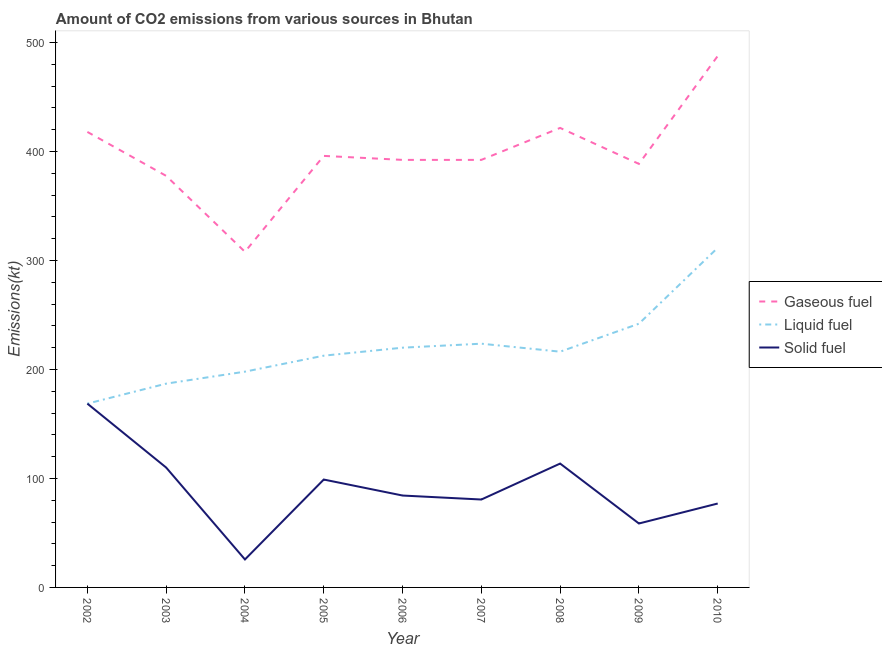Does the line corresponding to amount of co2 emissions from solid fuel intersect with the line corresponding to amount of co2 emissions from gaseous fuel?
Your response must be concise. No. Is the number of lines equal to the number of legend labels?
Offer a terse response. Yes. What is the amount of co2 emissions from solid fuel in 2006?
Your response must be concise. 84.34. Across all years, what is the maximum amount of co2 emissions from solid fuel?
Give a very brief answer. 168.68. Across all years, what is the minimum amount of co2 emissions from gaseous fuel?
Your response must be concise. 308.03. In which year was the amount of co2 emissions from gaseous fuel maximum?
Your answer should be very brief. 2010. In which year was the amount of co2 emissions from gaseous fuel minimum?
Your answer should be very brief. 2004. What is the total amount of co2 emissions from liquid fuel in the graph?
Your response must be concise. 1980.18. What is the difference between the amount of co2 emissions from gaseous fuel in 2008 and that in 2010?
Your response must be concise. -66.01. What is the difference between the amount of co2 emissions from gaseous fuel in 2010 and the amount of co2 emissions from solid fuel in 2009?
Keep it short and to the point. 429.04. What is the average amount of co2 emissions from gaseous fuel per year?
Offer a very short reply. 398.07. In the year 2010, what is the difference between the amount of co2 emissions from solid fuel and amount of co2 emissions from liquid fuel?
Offer a terse response. -234.69. In how many years, is the amount of co2 emissions from gaseous fuel greater than 120 kt?
Offer a very short reply. 9. What is the ratio of the amount of co2 emissions from gaseous fuel in 2005 to that in 2006?
Give a very brief answer. 1.01. Is the difference between the amount of co2 emissions from liquid fuel in 2002 and 2009 greater than the difference between the amount of co2 emissions from gaseous fuel in 2002 and 2009?
Your answer should be compact. No. What is the difference between the highest and the second highest amount of co2 emissions from liquid fuel?
Offer a very short reply. 69.67. What is the difference between the highest and the lowest amount of co2 emissions from solid fuel?
Your answer should be compact. 143.01. Is the sum of the amount of co2 emissions from liquid fuel in 2004 and 2008 greater than the maximum amount of co2 emissions from solid fuel across all years?
Keep it short and to the point. Yes. Is it the case that in every year, the sum of the amount of co2 emissions from gaseous fuel and amount of co2 emissions from liquid fuel is greater than the amount of co2 emissions from solid fuel?
Make the answer very short. Yes. Is the amount of co2 emissions from gaseous fuel strictly greater than the amount of co2 emissions from liquid fuel over the years?
Provide a short and direct response. Yes. Are the values on the major ticks of Y-axis written in scientific E-notation?
Ensure brevity in your answer.  No. Does the graph contain any zero values?
Offer a very short reply. No. Does the graph contain grids?
Your answer should be compact. No. How are the legend labels stacked?
Your answer should be compact. Vertical. What is the title of the graph?
Make the answer very short. Amount of CO2 emissions from various sources in Bhutan. What is the label or title of the Y-axis?
Your answer should be very brief. Emissions(kt). What is the Emissions(kt) in Gaseous fuel in 2002?
Give a very brief answer. 418.04. What is the Emissions(kt) of Liquid fuel in 2002?
Provide a short and direct response. 168.68. What is the Emissions(kt) of Solid fuel in 2002?
Ensure brevity in your answer.  168.68. What is the Emissions(kt) in Gaseous fuel in 2003?
Keep it short and to the point. 377.7. What is the Emissions(kt) in Liquid fuel in 2003?
Keep it short and to the point. 187.02. What is the Emissions(kt) of Solid fuel in 2003?
Your answer should be very brief. 110.01. What is the Emissions(kt) in Gaseous fuel in 2004?
Your answer should be compact. 308.03. What is the Emissions(kt) of Liquid fuel in 2004?
Provide a short and direct response. 198.02. What is the Emissions(kt) in Solid fuel in 2004?
Keep it short and to the point. 25.67. What is the Emissions(kt) in Gaseous fuel in 2005?
Keep it short and to the point. 396.04. What is the Emissions(kt) in Liquid fuel in 2005?
Provide a succinct answer. 212.69. What is the Emissions(kt) in Solid fuel in 2005?
Ensure brevity in your answer.  99.01. What is the Emissions(kt) in Gaseous fuel in 2006?
Keep it short and to the point. 392.37. What is the Emissions(kt) in Liquid fuel in 2006?
Provide a short and direct response. 220.02. What is the Emissions(kt) of Solid fuel in 2006?
Offer a very short reply. 84.34. What is the Emissions(kt) of Gaseous fuel in 2007?
Your answer should be very brief. 392.37. What is the Emissions(kt) of Liquid fuel in 2007?
Give a very brief answer. 223.69. What is the Emissions(kt) of Solid fuel in 2007?
Ensure brevity in your answer.  80.67. What is the Emissions(kt) of Gaseous fuel in 2008?
Give a very brief answer. 421.7. What is the Emissions(kt) in Liquid fuel in 2008?
Your response must be concise. 216.35. What is the Emissions(kt) in Solid fuel in 2008?
Offer a terse response. 113.68. What is the Emissions(kt) of Gaseous fuel in 2009?
Offer a very short reply. 388.7. What is the Emissions(kt) of Liquid fuel in 2009?
Keep it short and to the point. 242.02. What is the Emissions(kt) in Solid fuel in 2009?
Make the answer very short. 58.67. What is the Emissions(kt) of Gaseous fuel in 2010?
Your response must be concise. 487.71. What is the Emissions(kt) of Liquid fuel in 2010?
Offer a terse response. 311.69. What is the Emissions(kt) of Solid fuel in 2010?
Keep it short and to the point. 77.01. Across all years, what is the maximum Emissions(kt) of Gaseous fuel?
Give a very brief answer. 487.71. Across all years, what is the maximum Emissions(kt) of Liquid fuel?
Keep it short and to the point. 311.69. Across all years, what is the maximum Emissions(kt) of Solid fuel?
Give a very brief answer. 168.68. Across all years, what is the minimum Emissions(kt) of Gaseous fuel?
Offer a terse response. 308.03. Across all years, what is the minimum Emissions(kt) in Liquid fuel?
Your answer should be very brief. 168.68. Across all years, what is the minimum Emissions(kt) in Solid fuel?
Your answer should be very brief. 25.67. What is the total Emissions(kt) in Gaseous fuel in the graph?
Provide a short and direct response. 3582.66. What is the total Emissions(kt) of Liquid fuel in the graph?
Ensure brevity in your answer.  1980.18. What is the total Emissions(kt) in Solid fuel in the graph?
Offer a terse response. 817.74. What is the difference between the Emissions(kt) in Gaseous fuel in 2002 and that in 2003?
Offer a very short reply. 40.34. What is the difference between the Emissions(kt) of Liquid fuel in 2002 and that in 2003?
Keep it short and to the point. -18.34. What is the difference between the Emissions(kt) in Solid fuel in 2002 and that in 2003?
Provide a short and direct response. 58.67. What is the difference between the Emissions(kt) of Gaseous fuel in 2002 and that in 2004?
Provide a succinct answer. 110.01. What is the difference between the Emissions(kt) of Liquid fuel in 2002 and that in 2004?
Your answer should be very brief. -29.34. What is the difference between the Emissions(kt) in Solid fuel in 2002 and that in 2004?
Ensure brevity in your answer.  143.01. What is the difference between the Emissions(kt) in Gaseous fuel in 2002 and that in 2005?
Ensure brevity in your answer.  22. What is the difference between the Emissions(kt) in Liquid fuel in 2002 and that in 2005?
Give a very brief answer. -44. What is the difference between the Emissions(kt) of Solid fuel in 2002 and that in 2005?
Ensure brevity in your answer.  69.67. What is the difference between the Emissions(kt) in Gaseous fuel in 2002 and that in 2006?
Make the answer very short. 25.67. What is the difference between the Emissions(kt) of Liquid fuel in 2002 and that in 2006?
Offer a very short reply. -51.34. What is the difference between the Emissions(kt) in Solid fuel in 2002 and that in 2006?
Provide a succinct answer. 84.34. What is the difference between the Emissions(kt) in Gaseous fuel in 2002 and that in 2007?
Provide a short and direct response. 25.67. What is the difference between the Emissions(kt) in Liquid fuel in 2002 and that in 2007?
Offer a very short reply. -55.01. What is the difference between the Emissions(kt) in Solid fuel in 2002 and that in 2007?
Provide a succinct answer. 88.01. What is the difference between the Emissions(kt) in Gaseous fuel in 2002 and that in 2008?
Provide a short and direct response. -3.67. What is the difference between the Emissions(kt) of Liquid fuel in 2002 and that in 2008?
Give a very brief answer. -47.67. What is the difference between the Emissions(kt) in Solid fuel in 2002 and that in 2008?
Give a very brief answer. 55.01. What is the difference between the Emissions(kt) in Gaseous fuel in 2002 and that in 2009?
Your answer should be very brief. 29.34. What is the difference between the Emissions(kt) of Liquid fuel in 2002 and that in 2009?
Make the answer very short. -73.34. What is the difference between the Emissions(kt) of Solid fuel in 2002 and that in 2009?
Ensure brevity in your answer.  110.01. What is the difference between the Emissions(kt) in Gaseous fuel in 2002 and that in 2010?
Ensure brevity in your answer.  -69.67. What is the difference between the Emissions(kt) in Liquid fuel in 2002 and that in 2010?
Your answer should be compact. -143.01. What is the difference between the Emissions(kt) in Solid fuel in 2002 and that in 2010?
Provide a succinct answer. 91.67. What is the difference between the Emissions(kt) of Gaseous fuel in 2003 and that in 2004?
Ensure brevity in your answer.  69.67. What is the difference between the Emissions(kt) of Liquid fuel in 2003 and that in 2004?
Give a very brief answer. -11. What is the difference between the Emissions(kt) in Solid fuel in 2003 and that in 2004?
Give a very brief answer. 84.34. What is the difference between the Emissions(kt) in Gaseous fuel in 2003 and that in 2005?
Give a very brief answer. -18.34. What is the difference between the Emissions(kt) in Liquid fuel in 2003 and that in 2005?
Give a very brief answer. -25.67. What is the difference between the Emissions(kt) in Solid fuel in 2003 and that in 2005?
Give a very brief answer. 11. What is the difference between the Emissions(kt) of Gaseous fuel in 2003 and that in 2006?
Your answer should be very brief. -14.67. What is the difference between the Emissions(kt) in Liquid fuel in 2003 and that in 2006?
Your answer should be compact. -33. What is the difference between the Emissions(kt) of Solid fuel in 2003 and that in 2006?
Your response must be concise. 25.67. What is the difference between the Emissions(kt) of Gaseous fuel in 2003 and that in 2007?
Offer a terse response. -14.67. What is the difference between the Emissions(kt) of Liquid fuel in 2003 and that in 2007?
Offer a very short reply. -36.67. What is the difference between the Emissions(kt) of Solid fuel in 2003 and that in 2007?
Your response must be concise. 29.34. What is the difference between the Emissions(kt) in Gaseous fuel in 2003 and that in 2008?
Give a very brief answer. -44. What is the difference between the Emissions(kt) in Liquid fuel in 2003 and that in 2008?
Your answer should be very brief. -29.34. What is the difference between the Emissions(kt) of Solid fuel in 2003 and that in 2008?
Your response must be concise. -3.67. What is the difference between the Emissions(kt) in Gaseous fuel in 2003 and that in 2009?
Keep it short and to the point. -11. What is the difference between the Emissions(kt) in Liquid fuel in 2003 and that in 2009?
Ensure brevity in your answer.  -55.01. What is the difference between the Emissions(kt) of Solid fuel in 2003 and that in 2009?
Offer a very short reply. 51.34. What is the difference between the Emissions(kt) of Gaseous fuel in 2003 and that in 2010?
Make the answer very short. -110.01. What is the difference between the Emissions(kt) in Liquid fuel in 2003 and that in 2010?
Your response must be concise. -124.68. What is the difference between the Emissions(kt) of Solid fuel in 2003 and that in 2010?
Your answer should be compact. 33. What is the difference between the Emissions(kt) in Gaseous fuel in 2004 and that in 2005?
Your answer should be compact. -88.01. What is the difference between the Emissions(kt) of Liquid fuel in 2004 and that in 2005?
Your answer should be compact. -14.67. What is the difference between the Emissions(kt) of Solid fuel in 2004 and that in 2005?
Ensure brevity in your answer.  -73.34. What is the difference between the Emissions(kt) of Gaseous fuel in 2004 and that in 2006?
Your answer should be very brief. -84.34. What is the difference between the Emissions(kt) in Liquid fuel in 2004 and that in 2006?
Offer a terse response. -22. What is the difference between the Emissions(kt) in Solid fuel in 2004 and that in 2006?
Give a very brief answer. -58.67. What is the difference between the Emissions(kt) of Gaseous fuel in 2004 and that in 2007?
Offer a terse response. -84.34. What is the difference between the Emissions(kt) in Liquid fuel in 2004 and that in 2007?
Offer a terse response. -25.67. What is the difference between the Emissions(kt) in Solid fuel in 2004 and that in 2007?
Make the answer very short. -55.01. What is the difference between the Emissions(kt) of Gaseous fuel in 2004 and that in 2008?
Ensure brevity in your answer.  -113.68. What is the difference between the Emissions(kt) in Liquid fuel in 2004 and that in 2008?
Offer a very short reply. -18.34. What is the difference between the Emissions(kt) of Solid fuel in 2004 and that in 2008?
Keep it short and to the point. -88.01. What is the difference between the Emissions(kt) of Gaseous fuel in 2004 and that in 2009?
Your answer should be very brief. -80.67. What is the difference between the Emissions(kt) in Liquid fuel in 2004 and that in 2009?
Offer a terse response. -44. What is the difference between the Emissions(kt) of Solid fuel in 2004 and that in 2009?
Provide a succinct answer. -33. What is the difference between the Emissions(kt) of Gaseous fuel in 2004 and that in 2010?
Keep it short and to the point. -179.68. What is the difference between the Emissions(kt) in Liquid fuel in 2004 and that in 2010?
Give a very brief answer. -113.68. What is the difference between the Emissions(kt) of Solid fuel in 2004 and that in 2010?
Ensure brevity in your answer.  -51.34. What is the difference between the Emissions(kt) in Gaseous fuel in 2005 and that in 2006?
Make the answer very short. 3.67. What is the difference between the Emissions(kt) of Liquid fuel in 2005 and that in 2006?
Offer a terse response. -7.33. What is the difference between the Emissions(kt) of Solid fuel in 2005 and that in 2006?
Keep it short and to the point. 14.67. What is the difference between the Emissions(kt) in Gaseous fuel in 2005 and that in 2007?
Your answer should be very brief. 3.67. What is the difference between the Emissions(kt) in Liquid fuel in 2005 and that in 2007?
Provide a short and direct response. -11. What is the difference between the Emissions(kt) of Solid fuel in 2005 and that in 2007?
Make the answer very short. 18.34. What is the difference between the Emissions(kt) of Gaseous fuel in 2005 and that in 2008?
Provide a short and direct response. -25.67. What is the difference between the Emissions(kt) in Liquid fuel in 2005 and that in 2008?
Provide a succinct answer. -3.67. What is the difference between the Emissions(kt) in Solid fuel in 2005 and that in 2008?
Ensure brevity in your answer.  -14.67. What is the difference between the Emissions(kt) of Gaseous fuel in 2005 and that in 2009?
Your answer should be very brief. 7.33. What is the difference between the Emissions(kt) in Liquid fuel in 2005 and that in 2009?
Your response must be concise. -29.34. What is the difference between the Emissions(kt) in Solid fuel in 2005 and that in 2009?
Give a very brief answer. 40.34. What is the difference between the Emissions(kt) of Gaseous fuel in 2005 and that in 2010?
Your answer should be very brief. -91.67. What is the difference between the Emissions(kt) in Liquid fuel in 2005 and that in 2010?
Offer a very short reply. -99.01. What is the difference between the Emissions(kt) of Solid fuel in 2005 and that in 2010?
Make the answer very short. 22. What is the difference between the Emissions(kt) in Gaseous fuel in 2006 and that in 2007?
Provide a succinct answer. 0. What is the difference between the Emissions(kt) of Liquid fuel in 2006 and that in 2007?
Your response must be concise. -3.67. What is the difference between the Emissions(kt) in Solid fuel in 2006 and that in 2007?
Offer a very short reply. 3.67. What is the difference between the Emissions(kt) of Gaseous fuel in 2006 and that in 2008?
Offer a terse response. -29.34. What is the difference between the Emissions(kt) of Liquid fuel in 2006 and that in 2008?
Provide a short and direct response. 3.67. What is the difference between the Emissions(kt) of Solid fuel in 2006 and that in 2008?
Keep it short and to the point. -29.34. What is the difference between the Emissions(kt) in Gaseous fuel in 2006 and that in 2009?
Provide a short and direct response. 3.67. What is the difference between the Emissions(kt) in Liquid fuel in 2006 and that in 2009?
Offer a terse response. -22. What is the difference between the Emissions(kt) in Solid fuel in 2006 and that in 2009?
Keep it short and to the point. 25.67. What is the difference between the Emissions(kt) in Gaseous fuel in 2006 and that in 2010?
Provide a succinct answer. -95.34. What is the difference between the Emissions(kt) of Liquid fuel in 2006 and that in 2010?
Keep it short and to the point. -91.67. What is the difference between the Emissions(kt) of Solid fuel in 2006 and that in 2010?
Keep it short and to the point. 7.33. What is the difference between the Emissions(kt) in Gaseous fuel in 2007 and that in 2008?
Keep it short and to the point. -29.34. What is the difference between the Emissions(kt) of Liquid fuel in 2007 and that in 2008?
Offer a terse response. 7.33. What is the difference between the Emissions(kt) in Solid fuel in 2007 and that in 2008?
Provide a short and direct response. -33. What is the difference between the Emissions(kt) of Gaseous fuel in 2007 and that in 2009?
Keep it short and to the point. 3.67. What is the difference between the Emissions(kt) of Liquid fuel in 2007 and that in 2009?
Offer a terse response. -18.34. What is the difference between the Emissions(kt) of Solid fuel in 2007 and that in 2009?
Keep it short and to the point. 22. What is the difference between the Emissions(kt) in Gaseous fuel in 2007 and that in 2010?
Your response must be concise. -95.34. What is the difference between the Emissions(kt) of Liquid fuel in 2007 and that in 2010?
Your response must be concise. -88.01. What is the difference between the Emissions(kt) of Solid fuel in 2007 and that in 2010?
Offer a very short reply. 3.67. What is the difference between the Emissions(kt) in Gaseous fuel in 2008 and that in 2009?
Ensure brevity in your answer.  33. What is the difference between the Emissions(kt) in Liquid fuel in 2008 and that in 2009?
Make the answer very short. -25.67. What is the difference between the Emissions(kt) of Solid fuel in 2008 and that in 2009?
Provide a succinct answer. 55.01. What is the difference between the Emissions(kt) in Gaseous fuel in 2008 and that in 2010?
Your response must be concise. -66.01. What is the difference between the Emissions(kt) in Liquid fuel in 2008 and that in 2010?
Ensure brevity in your answer.  -95.34. What is the difference between the Emissions(kt) in Solid fuel in 2008 and that in 2010?
Offer a terse response. 36.67. What is the difference between the Emissions(kt) of Gaseous fuel in 2009 and that in 2010?
Your response must be concise. -99.01. What is the difference between the Emissions(kt) of Liquid fuel in 2009 and that in 2010?
Offer a terse response. -69.67. What is the difference between the Emissions(kt) of Solid fuel in 2009 and that in 2010?
Provide a succinct answer. -18.34. What is the difference between the Emissions(kt) of Gaseous fuel in 2002 and the Emissions(kt) of Liquid fuel in 2003?
Your answer should be compact. 231.02. What is the difference between the Emissions(kt) in Gaseous fuel in 2002 and the Emissions(kt) in Solid fuel in 2003?
Your response must be concise. 308.03. What is the difference between the Emissions(kt) in Liquid fuel in 2002 and the Emissions(kt) in Solid fuel in 2003?
Give a very brief answer. 58.67. What is the difference between the Emissions(kt) of Gaseous fuel in 2002 and the Emissions(kt) of Liquid fuel in 2004?
Give a very brief answer. 220.02. What is the difference between the Emissions(kt) in Gaseous fuel in 2002 and the Emissions(kt) in Solid fuel in 2004?
Provide a succinct answer. 392.37. What is the difference between the Emissions(kt) in Liquid fuel in 2002 and the Emissions(kt) in Solid fuel in 2004?
Keep it short and to the point. 143.01. What is the difference between the Emissions(kt) in Gaseous fuel in 2002 and the Emissions(kt) in Liquid fuel in 2005?
Ensure brevity in your answer.  205.35. What is the difference between the Emissions(kt) of Gaseous fuel in 2002 and the Emissions(kt) of Solid fuel in 2005?
Keep it short and to the point. 319.03. What is the difference between the Emissions(kt) of Liquid fuel in 2002 and the Emissions(kt) of Solid fuel in 2005?
Offer a terse response. 69.67. What is the difference between the Emissions(kt) of Gaseous fuel in 2002 and the Emissions(kt) of Liquid fuel in 2006?
Provide a succinct answer. 198.02. What is the difference between the Emissions(kt) in Gaseous fuel in 2002 and the Emissions(kt) in Solid fuel in 2006?
Provide a succinct answer. 333.7. What is the difference between the Emissions(kt) in Liquid fuel in 2002 and the Emissions(kt) in Solid fuel in 2006?
Offer a terse response. 84.34. What is the difference between the Emissions(kt) in Gaseous fuel in 2002 and the Emissions(kt) in Liquid fuel in 2007?
Provide a short and direct response. 194.35. What is the difference between the Emissions(kt) of Gaseous fuel in 2002 and the Emissions(kt) of Solid fuel in 2007?
Your answer should be very brief. 337.36. What is the difference between the Emissions(kt) of Liquid fuel in 2002 and the Emissions(kt) of Solid fuel in 2007?
Your answer should be very brief. 88.01. What is the difference between the Emissions(kt) in Gaseous fuel in 2002 and the Emissions(kt) in Liquid fuel in 2008?
Provide a succinct answer. 201.69. What is the difference between the Emissions(kt) of Gaseous fuel in 2002 and the Emissions(kt) of Solid fuel in 2008?
Make the answer very short. 304.36. What is the difference between the Emissions(kt) in Liquid fuel in 2002 and the Emissions(kt) in Solid fuel in 2008?
Your answer should be compact. 55.01. What is the difference between the Emissions(kt) in Gaseous fuel in 2002 and the Emissions(kt) in Liquid fuel in 2009?
Keep it short and to the point. 176.02. What is the difference between the Emissions(kt) in Gaseous fuel in 2002 and the Emissions(kt) in Solid fuel in 2009?
Provide a succinct answer. 359.37. What is the difference between the Emissions(kt) of Liquid fuel in 2002 and the Emissions(kt) of Solid fuel in 2009?
Offer a very short reply. 110.01. What is the difference between the Emissions(kt) of Gaseous fuel in 2002 and the Emissions(kt) of Liquid fuel in 2010?
Your response must be concise. 106.34. What is the difference between the Emissions(kt) of Gaseous fuel in 2002 and the Emissions(kt) of Solid fuel in 2010?
Make the answer very short. 341.03. What is the difference between the Emissions(kt) in Liquid fuel in 2002 and the Emissions(kt) in Solid fuel in 2010?
Provide a short and direct response. 91.67. What is the difference between the Emissions(kt) of Gaseous fuel in 2003 and the Emissions(kt) of Liquid fuel in 2004?
Give a very brief answer. 179.68. What is the difference between the Emissions(kt) of Gaseous fuel in 2003 and the Emissions(kt) of Solid fuel in 2004?
Ensure brevity in your answer.  352.03. What is the difference between the Emissions(kt) of Liquid fuel in 2003 and the Emissions(kt) of Solid fuel in 2004?
Your response must be concise. 161.35. What is the difference between the Emissions(kt) in Gaseous fuel in 2003 and the Emissions(kt) in Liquid fuel in 2005?
Give a very brief answer. 165.01. What is the difference between the Emissions(kt) in Gaseous fuel in 2003 and the Emissions(kt) in Solid fuel in 2005?
Your answer should be compact. 278.69. What is the difference between the Emissions(kt) of Liquid fuel in 2003 and the Emissions(kt) of Solid fuel in 2005?
Your response must be concise. 88.01. What is the difference between the Emissions(kt) of Gaseous fuel in 2003 and the Emissions(kt) of Liquid fuel in 2006?
Give a very brief answer. 157.68. What is the difference between the Emissions(kt) of Gaseous fuel in 2003 and the Emissions(kt) of Solid fuel in 2006?
Offer a very short reply. 293.36. What is the difference between the Emissions(kt) of Liquid fuel in 2003 and the Emissions(kt) of Solid fuel in 2006?
Provide a short and direct response. 102.68. What is the difference between the Emissions(kt) in Gaseous fuel in 2003 and the Emissions(kt) in Liquid fuel in 2007?
Give a very brief answer. 154.01. What is the difference between the Emissions(kt) in Gaseous fuel in 2003 and the Emissions(kt) in Solid fuel in 2007?
Make the answer very short. 297.03. What is the difference between the Emissions(kt) of Liquid fuel in 2003 and the Emissions(kt) of Solid fuel in 2007?
Offer a very short reply. 106.34. What is the difference between the Emissions(kt) of Gaseous fuel in 2003 and the Emissions(kt) of Liquid fuel in 2008?
Provide a succinct answer. 161.35. What is the difference between the Emissions(kt) of Gaseous fuel in 2003 and the Emissions(kt) of Solid fuel in 2008?
Give a very brief answer. 264.02. What is the difference between the Emissions(kt) of Liquid fuel in 2003 and the Emissions(kt) of Solid fuel in 2008?
Your response must be concise. 73.34. What is the difference between the Emissions(kt) of Gaseous fuel in 2003 and the Emissions(kt) of Liquid fuel in 2009?
Provide a short and direct response. 135.68. What is the difference between the Emissions(kt) in Gaseous fuel in 2003 and the Emissions(kt) in Solid fuel in 2009?
Make the answer very short. 319.03. What is the difference between the Emissions(kt) in Liquid fuel in 2003 and the Emissions(kt) in Solid fuel in 2009?
Provide a short and direct response. 128.34. What is the difference between the Emissions(kt) in Gaseous fuel in 2003 and the Emissions(kt) in Liquid fuel in 2010?
Keep it short and to the point. 66.01. What is the difference between the Emissions(kt) of Gaseous fuel in 2003 and the Emissions(kt) of Solid fuel in 2010?
Offer a terse response. 300.69. What is the difference between the Emissions(kt) of Liquid fuel in 2003 and the Emissions(kt) of Solid fuel in 2010?
Your response must be concise. 110.01. What is the difference between the Emissions(kt) of Gaseous fuel in 2004 and the Emissions(kt) of Liquid fuel in 2005?
Keep it short and to the point. 95.34. What is the difference between the Emissions(kt) of Gaseous fuel in 2004 and the Emissions(kt) of Solid fuel in 2005?
Make the answer very short. 209.02. What is the difference between the Emissions(kt) in Liquid fuel in 2004 and the Emissions(kt) in Solid fuel in 2005?
Provide a succinct answer. 99.01. What is the difference between the Emissions(kt) in Gaseous fuel in 2004 and the Emissions(kt) in Liquid fuel in 2006?
Make the answer very short. 88.01. What is the difference between the Emissions(kt) of Gaseous fuel in 2004 and the Emissions(kt) of Solid fuel in 2006?
Offer a terse response. 223.69. What is the difference between the Emissions(kt) of Liquid fuel in 2004 and the Emissions(kt) of Solid fuel in 2006?
Provide a short and direct response. 113.68. What is the difference between the Emissions(kt) of Gaseous fuel in 2004 and the Emissions(kt) of Liquid fuel in 2007?
Offer a very short reply. 84.34. What is the difference between the Emissions(kt) in Gaseous fuel in 2004 and the Emissions(kt) in Solid fuel in 2007?
Make the answer very short. 227.35. What is the difference between the Emissions(kt) of Liquid fuel in 2004 and the Emissions(kt) of Solid fuel in 2007?
Provide a succinct answer. 117.34. What is the difference between the Emissions(kt) of Gaseous fuel in 2004 and the Emissions(kt) of Liquid fuel in 2008?
Offer a terse response. 91.67. What is the difference between the Emissions(kt) of Gaseous fuel in 2004 and the Emissions(kt) of Solid fuel in 2008?
Make the answer very short. 194.35. What is the difference between the Emissions(kt) of Liquid fuel in 2004 and the Emissions(kt) of Solid fuel in 2008?
Offer a terse response. 84.34. What is the difference between the Emissions(kt) in Gaseous fuel in 2004 and the Emissions(kt) in Liquid fuel in 2009?
Provide a succinct answer. 66.01. What is the difference between the Emissions(kt) of Gaseous fuel in 2004 and the Emissions(kt) of Solid fuel in 2009?
Your response must be concise. 249.36. What is the difference between the Emissions(kt) of Liquid fuel in 2004 and the Emissions(kt) of Solid fuel in 2009?
Your answer should be compact. 139.35. What is the difference between the Emissions(kt) of Gaseous fuel in 2004 and the Emissions(kt) of Liquid fuel in 2010?
Offer a terse response. -3.67. What is the difference between the Emissions(kt) in Gaseous fuel in 2004 and the Emissions(kt) in Solid fuel in 2010?
Offer a terse response. 231.02. What is the difference between the Emissions(kt) in Liquid fuel in 2004 and the Emissions(kt) in Solid fuel in 2010?
Your answer should be very brief. 121.01. What is the difference between the Emissions(kt) in Gaseous fuel in 2005 and the Emissions(kt) in Liquid fuel in 2006?
Give a very brief answer. 176.02. What is the difference between the Emissions(kt) of Gaseous fuel in 2005 and the Emissions(kt) of Solid fuel in 2006?
Offer a very short reply. 311.69. What is the difference between the Emissions(kt) in Liquid fuel in 2005 and the Emissions(kt) in Solid fuel in 2006?
Give a very brief answer. 128.34. What is the difference between the Emissions(kt) of Gaseous fuel in 2005 and the Emissions(kt) of Liquid fuel in 2007?
Provide a short and direct response. 172.35. What is the difference between the Emissions(kt) in Gaseous fuel in 2005 and the Emissions(kt) in Solid fuel in 2007?
Your response must be concise. 315.36. What is the difference between the Emissions(kt) of Liquid fuel in 2005 and the Emissions(kt) of Solid fuel in 2007?
Provide a succinct answer. 132.01. What is the difference between the Emissions(kt) in Gaseous fuel in 2005 and the Emissions(kt) in Liquid fuel in 2008?
Give a very brief answer. 179.68. What is the difference between the Emissions(kt) in Gaseous fuel in 2005 and the Emissions(kt) in Solid fuel in 2008?
Provide a short and direct response. 282.36. What is the difference between the Emissions(kt) of Liquid fuel in 2005 and the Emissions(kt) of Solid fuel in 2008?
Provide a short and direct response. 99.01. What is the difference between the Emissions(kt) of Gaseous fuel in 2005 and the Emissions(kt) of Liquid fuel in 2009?
Offer a terse response. 154.01. What is the difference between the Emissions(kt) of Gaseous fuel in 2005 and the Emissions(kt) of Solid fuel in 2009?
Make the answer very short. 337.36. What is the difference between the Emissions(kt) in Liquid fuel in 2005 and the Emissions(kt) in Solid fuel in 2009?
Make the answer very short. 154.01. What is the difference between the Emissions(kt) of Gaseous fuel in 2005 and the Emissions(kt) of Liquid fuel in 2010?
Keep it short and to the point. 84.34. What is the difference between the Emissions(kt) of Gaseous fuel in 2005 and the Emissions(kt) of Solid fuel in 2010?
Offer a terse response. 319.03. What is the difference between the Emissions(kt) of Liquid fuel in 2005 and the Emissions(kt) of Solid fuel in 2010?
Your response must be concise. 135.68. What is the difference between the Emissions(kt) in Gaseous fuel in 2006 and the Emissions(kt) in Liquid fuel in 2007?
Provide a succinct answer. 168.68. What is the difference between the Emissions(kt) of Gaseous fuel in 2006 and the Emissions(kt) of Solid fuel in 2007?
Make the answer very short. 311.69. What is the difference between the Emissions(kt) in Liquid fuel in 2006 and the Emissions(kt) in Solid fuel in 2007?
Make the answer very short. 139.35. What is the difference between the Emissions(kt) of Gaseous fuel in 2006 and the Emissions(kt) of Liquid fuel in 2008?
Ensure brevity in your answer.  176.02. What is the difference between the Emissions(kt) in Gaseous fuel in 2006 and the Emissions(kt) in Solid fuel in 2008?
Keep it short and to the point. 278.69. What is the difference between the Emissions(kt) of Liquid fuel in 2006 and the Emissions(kt) of Solid fuel in 2008?
Give a very brief answer. 106.34. What is the difference between the Emissions(kt) in Gaseous fuel in 2006 and the Emissions(kt) in Liquid fuel in 2009?
Your response must be concise. 150.35. What is the difference between the Emissions(kt) of Gaseous fuel in 2006 and the Emissions(kt) of Solid fuel in 2009?
Provide a succinct answer. 333.7. What is the difference between the Emissions(kt) in Liquid fuel in 2006 and the Emissions(kt) in Solid fuel in 2009?
Give a very brief answer. 161.35. What is the difference between the Emissions(kt) in Gaseous fuel in 2006 and the Emissions(kt) in Liquid fuel in 2010?
Your answer should be compact. 80.67. What is the difference between the Emissions(kt) in Gaseous fuel in 2006 and the Emissions(kt) in Solid fuel in 2010?
Provide a short and direct response. 315.36. What is the difference between the Emissions(kt) in Liquid fuel in 2006 and the Emissions(kt) in Solid fuel in 2010?
Keep it short and to the point. 143.01. What is the difference between the Emissions(kt) in Gaseous fuel in 2007 and the Emissions(kt) in Liquid fuel in 2008?
Your answer should be compact. 176.02. What is the difference between the Emissions(kt) of Gaseous fuel in 2007 and the Emissions(kt) of Solid fuel in 2008?
Offer a very short reply. 278.69. What is the difference between the Emissions(kt) of Liquid fuel in 2007 and the Emissions(kt) of Solid fuel in 2008?
Offer a very short reply. 110.01. What is the difference between the Emissions(kt) in Gaseous fuel in 2007 and the Emissions(kt) in Liquid fuel in 2009?
Provide a short and direct response. 150.35. What is the difference between the Emissions(kt) in Gaseous fuel in 2007 and the Emissions(kt) in Solid fuel in 2009?
Give a very brief answer. 333.7. What is the difference between the Emissions(kt) in Liquid fuel in 2007 and the Emissions(kt) in Solid fuel in 2009?
Ensure brevity in your answer.  165.01. What is the difference between the Emissions(kt) in Gaseous fuel in 2007 and the Emissions(kt) in Liquid fuel in 2010?
Keep it short and to the point. 80.67. What is the difference between the Emissions(kt) in Gaseous fuel in 2007 and the Emissions(kt) in Solid fuel in 2010?
Your response must be concise. 315.36. What is the difference between the Emissions(kt) in Liquid fuel in 2007 and the Emissions(kt) in Solid fuel in 2010?
Your answer should be compact. 146.68. What is the difference between the Emissions(kt) of Gaseous fuel in 2008 and the Emissions(kt) of Liquid fuel in 2009?
Provide a short and direct response. 179.68. What is the difference between the Emissions(kt) in Gaseous fuel in 2008 and the Emissions(kt) in Solid fuel in 2009?
Offer a terse response. 363.03. What is the difference between the Emissions(kt) of Liquid fuel in 2008 and the Emissions(kt) of Solid fuel in 2009?
Give a very brief answer. 157.68. What is the difference between the Emissions(kt) in Gaseous fuel in 2008 and the Emissions(kt) in Liquid fuel in 2010?
Your answer should be compact. 110.01. What is the difference between the Emissions(kt) in Gaseous fuel in 2008 and the Emissions(kt) in Solid fuel in 2010?
Your answer should be compact. 344.7. What is the difference between the Emissions(kt) in Liquid fuel in 2008 and the Emissions(kt) in Solid fuel in 2010?
Give a very brief answer. 139.35. What is the difference between the Emissions(kt) in Gaseous fuel in 2009 and the Emissions(kt) in Liquid fuel in 2010?
Your response must be concise. 77.01. What is the difference between the Emissions(kt) in Gaseous fuel in 2009 and the Emissions(kt) in Solid fuel in 2010?
Offer a very short reply. 311.69. What is the difference between the Emissions(kt) of Liquid fuel in 2009 and the Emissions(kt) of Solid fuel in 2010?
Offer a very short reply. 165.01. What is the average Emissions(kt) of Gaseous fuel per year?
Your answer should be compact. 398.07. What is the average Emissions(kt) in Liquid fuel per year?
Your answer should be very brief. 220.02. What is the average Emissions(kt) in Solid fuel per year?
Provide a short and direct response. 90.86. In the year 2002, what is the difference between the Emissions(kt) in Gaseous fuel and Emissions(kt) in Liquid fuel?
Your answer should be compact. 249.36. In the year 2002, what is the difference between the Emissions(kt) in Gaseous fuel and Emissions(kt) in Solid fuel?
Provide a succinct answer. 249.36. In the year 2002, what is the difference between the Emissions(kt) in Liquid fuel and Emissions(kt) in Solid fuel?
Provide a short and direct response. 0. In the year 2003, what is the difference between the Emissions(kt) in Gaseous fuel and Emissions(kt) in Liquid fuel?
Ensure brevity in your answer.  190.68. In the year 2003, what is the difference between the Emissions(kt) in Gaseous fuel and Emissions(kt) in Solid fuel?
Your answer should be very brief. 267.69. In the year 2003, what is the difference between the Emissions(kt) in Liquid fuel and Emissions(kt) in Solid fuel?
Offer a very short reply. 77.01. In the year 2004, what is the difference between the Emissions(kt) in Gaseous fuel and Emissions(kt) in Liquid fuel?
Your response must be concise. 110.01. In the year 2004, what is the difference between the Emissions(kt) of Gaseous fuel and Emissions(kt) of Solid fuel?
Your response must be concise. 282.36. In the year 2004, what is the difference between the Emissions(kt) in Liquid fuel and Emissions(kt) in Solid fuel?
Make the answer very short. 172.35. In the year 2005, what is the difference between the Emissions(kt) of Gaseous fuel and Emissions(kt) of Liquid fuel?
Make the answer very short. 183.35. In the year 2005, what is the difference between the Emissions(kt) of Gaseous fuel and Emissions(kt) of Solid fuel?
Your answer should be very brief. 297.03. In the year 2005, what is the difference between the Emissions(kt) of Liquid fuel and Emissions(kt) of Solid fuel?
Your answer should be very brief. 113.68. In the year 2006, what is the difference between the Emissions(kt) in Gaseous fuel and Emissions(kt) in Liquid fuel?
Provide a succinct answer. 172.35. In the year 2006, what is the difference between the Emissions(kt) of Gaseous fuel and Emissions(kt) of Solid fuel?
Your response must be concise. 308.03. In the year 2006, what is the difference between the Emissions(kt) in Liquid fuel and Emissions(kt) in Solid fuel?
Your answer should be compact. 135.68. In the year 2007, what is the difference between the Emissions(kt) of Gaseous fuel and Emissions(kt) of Liquid fuel?
Keep it short and to the point. 168.68. In the year 2007, what is the difference between the Emissions(kt) of Gaseous fuel and Emissions(kt) of Solid fuel?
Provide a short and direct response. 311.69. In the year 2007, what is the difference between the Emissions(kt) in Liquid fuel and Emissions(kt) in Solid fuel?
Offer a very short reply. 143.01. In the year 2008, what is the difference between the Emissions(kt) of Gaseous fuel and Emissions(kt) of Liquid fuel?
Give a very brief answer. 205.35. In the year 2008, what is the difference between the Emissions(kt) of Gaseous fuel and Emissions(kt) of Solid fuel?
Ensure brevity in your answer.  308.03. In the year 2008, what is the difference between the Emissions(kt) of Liquid fuel and Emissions(kt) of Solid fuel?
Keep it short and to the point. 102.68. In the year 2009, what is the difference between the Emissions(kt) of Gaseous fuel and Emissions(kt) of Liquid fuel?
Offer a terse response. 146.68. In the year 2009, what is the difference between the Emissions(kt) of Gaseous fuel and Emissions(kt) of Solid fuel?
Provide a short and direct response. 330.03. In the year 2009, what is the difference between the Emissions(kt) in Liquid fuel and Emissions(kt) in Solid fuel?
Provide a succinct answer. 183.35. In the year 2010, what is the difference between the Emissions(kt) of Gaseous fuel and Emissions(kt) of Liquid fuel?
Offer a terse response. 176.02. In the year 2010, what is the difference between the Emissions(kt) of Gaseous fuel and Emissions(kt) of Solid fuel?
Your answer should be compact. 410.7. In the year 2010, what is the difference between the Emissions(kt) in Liquid fuel and Emissions(kt) in Solid fuel?
Offer a very short reply. 234.69. What is the ratio of the Emissions(kt) in Gaseous fuel in 2002 to that in 2003?
Keep it short and to the point. 1.11. What is the ratio of the Emissions(kt) in Liquid fuel in 2002 to that in 2003?
Your answer should be compact. 0.9. What is the ratio of the Emissions(kt) in Solid fuel in 2002 to that in 2003?
Your answer should be compact. 1.53. What is the ratio of the Emissions(kt) in Gaseous fuel in 2002 to that in 2004?
Offer a terse response. 1.36. What is the ratio of the Emissions(kt) of Liquid fuel in 2002 to that in 2004?
Your answer should be very brief. 0.85. What is the ratio of the Emissions(kt) of Solid fuel in 2002 to that in 2004?
Offer a very short reply. 6.57. What is the ratio of the Emissions(kt) in Gaseous fuel in 2002 to that in 2005?
Provide a succinct answer. 1.06. What is the ratio of the Emissions(kt) in Liquid fuel in 2002 to that in 2005?
Make the answer very short. 0.79. What is the ratio of the Emissions(kt) in Solid fuel in 2002 to that in 2005?
Your answer should be very brief. 1.7. What is the ratio of the Emissions(kt) of Gaseous fuel in 2002 to that in 2006?
Offer a terse response. 1.07. What is the ratio of the Emissions(kt) in Liquid fuel in 2002 to that in 2006?
Make the answer very short. 0.77. What is the ratio of the Emissions(kt) of Gaseous fuel in 2002 to that in 2007?
Provide a succinct answer. 1.07. What is the ratio of the Emissions(kt) in Liquid fuel in 2002 to that in 2007?
Make the answer very short. 0.75. What is the ratio of the Emissions(kt) of Solid fuel in 2002 to that in 2007?
Make the answer very short. 2.09. What is the ratio of the Emissions(kt) in Liquid fuel in 2002 to that in 2008?
Your answer should be compact. 0.78. What is the ratio of the Emissions(kt) in Solid fuel in 2002 to that in 2008?
Give a very brief answer. 1.48. What is the ratio of the Emissions(kt) in Gaseous fuel in 2002 to that in 2009?
Your answer should be very brief. 1.08. What is the ratio of the Emissions(kt) of Liquid fuel in 2002 to that in 2009?
Make the answer very short. 0.7. What is the ratio of the Emissions(kt) of Solid fuel in 2002 to that in 2009?
Offer a very short reply. 2.88. What is the ratio of the Emissions(kt) in Liquid fuel in 2002 to that in 2010?
Make the answer very short. 0.54. What is the ratio of the Emissions(kt) of Solid fuel in 2002 to that in 2010?
Keep it short and to the point. 2.19. What is the ratio of the Emissions(kt) in Gaseous fuel in 2003 to that in 2004?
Your response must be concise. 1.23. What is the ratio of the Emissions(kt) of Liquid fuel in 2003 to that in 2004?
Offer a terse response. 0.94. What is the ratio of the Emissions(kt) of Solid fuel in 2003 to that in 2004?
Your answer should be compact. 4.29. What is the ratio of the Emissions(kt) in Gaseous fuel in 2003 to that in 2005?
Make the answer very short. 0.95. What is the ratio of the Emissions(kt) in Liquid fuel in 2003 to that in 2005?
Give a very brief answer. 0.88. What is the ratio of the Emissions(kt) of Solid fuel in 2003 to that in 2005?
Give a very brief answer. 1.11. What is the ratio of the Emissions(kt) in Gaseous fuel in 2003 to that in 2006?
Provide a short and direct response. 0.96. What is the ratio of the Emissions(kt) of Solid fuel in 2003 to that in 2006?
Give a very brief answer. 1.3. What is the ratio of the Emissions(kt) of Gaseous fuel in 2003 to that in 2007?
Ensure brevity in your answer.  0.96. What is the ratio of the Emissions(kt) in Liquid fuel in 2003 to that in 2007?
Your answer should be compact. 0.84. What is the ratio of the Emissions(kt) of Solid fuel in 2003 to that in 2007?
Offer a very short reply. 1.36. What is the ratio of the Emissions(kt) in Gaseous fuel in 2003 to that in 2008?
Your response must be concise. 0.9. What is the ratio of the Emissions(kt) in Liquid fuel in 2003 to that in 2008?
Make the answer very short. 0.86. What is the ratio of the Emissions(kt) of Gaseous fuel in 2003 to that in 2009?
Provide a succinct answer. 0.97. What is the ratio of the Emissions(kt) in Liquid fuel in 2003 to that in 2009?
Offer a very short reply. 0.77. What is the ratio of the Emissions(kt) in Solid fuel in 2003 to that in 2009?
Your answer should be compact. 1.88. What is the ratio of the Emissions(kt) in Gaseous fuel in 2003 to that in 2010?
Make the answer very short. 0.77. What is the ratio of the Emissions(kt) of Liquid fuel in 2003 to that in 2010?
Keep it short and to the point. 0.6. What is the ratio of the Emissions(kt) of Solid fuel in 2003 to that in 2010?
Your response must be concise. 1.43. What is the ratio of the Emissions(kt) in Liquid fuel in 2004 to that in 2005?
Your response must be concise. 0.93. What is the ratio of the Emissions(kt) in Solid fuel in 2004 to that in 2005?
Provide a short and direct response. 0.26. What is the ratio of the Emissions(kt) of Gaseous fuel in 2004 to that in 2006?
Provide a succinct answer. 0.79. What is the ratio of the Emissions(kt) of Liquid fuel in 2004 to that in 2006?
Ensure brevity in your answer.  0.9. What is the ratio of the Emissions(kt) in Solid fuel in 2004 to that in 2006?
Ensure brevity in your answer.  0.3. What is the ratio of the Emissions(kt) in Gaseous fuel in 2004 to that in 2007?
Provide a succinct answer. 0.79. What is the ratio of the Emissions(kt) in Liquid fuel in 2004 to that in 2007?
Offer a very short reply. 0.89. What is the ratio of the Emissions(kt) of Solid fuel in 2004 to that in 2007?
Your answer should be very brief. 0.32. What is the ratio of the Emissions(kt) of Gaseous fuel in 2004 to that in 2008?
Offer a very short reply. 0.73. What is the ratio of the Emissions(kt) in Liquid fuel in 2004 to that in 2008?
Offer a terse response. 0.92. What is the ratio of the Emissions(kt) of Solid fuel in 2004 to that in 2008?
Provide a short and direct response. 0.23. What is the ratio of the Emissions(kt) in Gaseous fuel in 2004 to that in 2009?
Your response must be concise. 0.79. What is the ratio of the Emissions(kt) of Liquid fuel in 2004 to that in 2009?
Your response must be concise. 0.82. What is the ratio of the Emissions(kt) of Solid fuel in 2004 to that in 2009?
Ensure brevity in your answer.  0.44. What is the ratio of the Emissions(kt) in Gaseous fuel in 2004 to that in 2010?
Make the answer very short. 0.63. What is the ratio of the Emissions(kt) of Liquid fuel in 2004 to that in 2010?
Offer a terse response. 0.64. What is the ratio of the Emissions(kt) in Solid fuel in 2004 to that in 2010?
Keep it short and to the point. 0.33. What is the ratio of the Emissions(kt) of Gaseous fuel in 2005 to that in 2006?
Give a very brief answer. 1.01. What is the ratio of the Emissions(kt) in Liquid fuel in 2005 to that in 2006?
Your response must be concise. 0.97. What is the ratio of the Emissions(kt) in Solid fuel in 2005 to that in 2006?
Give a very brief answer. 1.17. What is the ratio of the Emissions(kt) of Gaseous fuel in 2005 to that in 2007?
Make the answer very short. 1.01. What is the ratio of the Emissions(kt) of Liquid fuel in 2005 to that in 2007?
Offer a very short reply. 0.95. What is the ratio of the Emissions(kt) in Solid fuel in 2005 to that in 2007?
Give a very brief answer. 1.23. What is the ratio of the Emissions(kt) in Gaseous fuel in 2005 to that in 2008?
Provide a succinct answer. 0.94. What is the ratio of the Emissions(kt) of Liquid fuel in 2005 to that in 2008?
Your response must be concise. 0.98. What is the ratio of the Emissions(kt) in Solid fuel in 2005 to that in 2008?
Provide a short and direct response. 0.87. What is the ratio of the Emissions(kt) of Gaseous fuel in 2005 to that in 2009?
Keep it short and to the point. 1.02. What is the ratio of the Emissions(kt) in Liquid fuel in 2005 to that in 2009?
Provide a short and direct response. 0.88. What is the ratio of the Emissions(kt) of Solid fuel in 2005 to that in 2009?
Make the answer very short. 1.69. What is the ratio of the Emissions(kt) of Gaseous fuel in 2005 to that in 2010?
Provide a short and direct response. 0.81. What is the ratio of the Emissions(kt) of Liquid fuel in 2005 to that in 2010?
Your answer should be compact. 0.68. What is the ratio of the Emissions(kt) in Solid fuel in 2005 to that in 2010?
Keep it short and to the point. 1.29. What is the ratio of the Emissions(kt) of Gaseous fuel in 2006 to that in 2007?
Keep it short and to the point. 1. What is the ratio of the Emissions(kt) of Liquid fuel in 2006 to that in 2007?
Keep it short and to the point. 0.98. What is the ratio of the Emissions(kt) of Solid fuel in 2006 to that in 2007?
Offer a very short reply. 1.05. What is the ratio of the Emissions(kt) in Gaseous fuel in 2006 to that in 2008?
Ensure brevity in your answer.  0.93. What is the ratio of the Emissions(kt) in Liquid fuel in 2006 to that in 2008?
Keep it short and to the point. 1.02. What is the ratio of the Emissions(kt) in Solid fuel in 2006 to that in 2008?
Your answer should be compact. 0.74. What is the ratio of the Emissions(kt) in Gaseous fuel in 2006 to that in 2009?
Give a very brief answer. 1.01. What is the ratio of the Emissions(kt) of Solid fuel in 2006 to that in 2009?
Give a very brief answer. 1.44. What is the ratio of the Emissions(kt) of Gaseous fuel in 2006 to that in 2010?
Your answer should be compact. 0.8. What is the ratio of the Emissions(kt) of Liquid fuel in 2006 to that in 2010?
Your answer should be compact. 0.71. What is the ratio of the Emissions(kt) of Solid fuel in 2006 to that in 2010?
Make the answer very short. 1.1. What is the ratio of the Emissions(kt) in Gaseous fuel in 2007 to that in 2008?
Ensure brevity in your answer.  0.93. What is the ratio of the Emissions(kt) of Liquid fuel in 2007 to that in 2008?
Ensure brevity in your answer.  1.03. What is the ratio of the Emissions(kt) in Solid fuel in 2007 to that in 2008?
Give a very brief answer. 0.71. What is the ratio of the Emissions(kt) in Gaseous fuel in 2007 to that in 2009?
Your response must be concise. 1.01. What is the ratio of the Emissions(kt) in Liquid fuel in 2007 to that in 2009?
Give a very brief answer. 0.92. What is the ratio of the Emissions(kt) in Solid fuel in 2007 to that in 2009?
Your answer should be very brief. 1.38. What is the ratio of the Emissions(kt) in Gaseous fuel in 2007 to that in 2010?
Keep it short and to the point. 0.8. What is the ratio of the Emissions(kt) of Liquid fuel in 2007 to that in 2010?
Your response must be concise. 0.72. What is the ratio of the Emissions(kt) in Solid fuel in 2007 to that in 2010?
Give a very brief answer. 1.05. What is the ratio of the Emissions(kt) in Gaseous fuel in 2008 to that in 2009?
Offer a very short reply. 1.08. What is the ratio of the Emissions(kt) in Liquid fuel in 2008 to that in 2009?
Provide a succinct answer. 0.89. What is the ratio of the Emissions(kt) in Solid fuel in 2008 to that in 2009?
Provide a short and direct response. 1.94. What is the ratio of the Emissions(kt) of Gaseous fuel in 2008 to that in 2010?
Make the answer very short. 0.86. What is the ratio of the Emissions(kt) in Liquid fuel in 2008 to that in 2010?
Keep it short and to the point. 0.69. What is the ratio of the Emissions(kt) in Solid fuel in 2008 to that in 2010?
Offer a very short reply. 1.48. What is the ratio of the Emissions(kt) in Gaseous fuel in 2009 to that in 2010?
Provide a succinct answer. 0.8. What is the ratio of the Emissions(kt) in Liquid fuel in 2009 to that in 2010?
Ensure brevity in your answer.  0.78. What is the ratio of the Emissions(kt) of Solid fuel in 2009 to that in 2010?
Offer a terse response. 0.76. What is the difference between the highest and the second highest Emissions(kt) in Gaseous fuel?
Offer a terse response. 66.01. What is the difference between the highest and the second highest Emissions(kt) in Liquid fuel?
Offer a terse response. 69.67. What is the difference between the highest and the second highest Emissions(kt) of Solid fuel?
Your answer should be very brief. 55.01. What is the difference between the highest and the lowest Emissions(kt) in Gaseous fuel?
Ensure brevity in your answer.  179.68. What is the difference between the highest and the lowest Emissions(kt) in Liquid fuel?
Keep it short and to the point. 143.01. What is the difference between the highest and the lowest Emissions(kt) of Solid fuel?
Your answer should be compact. 143.01. 